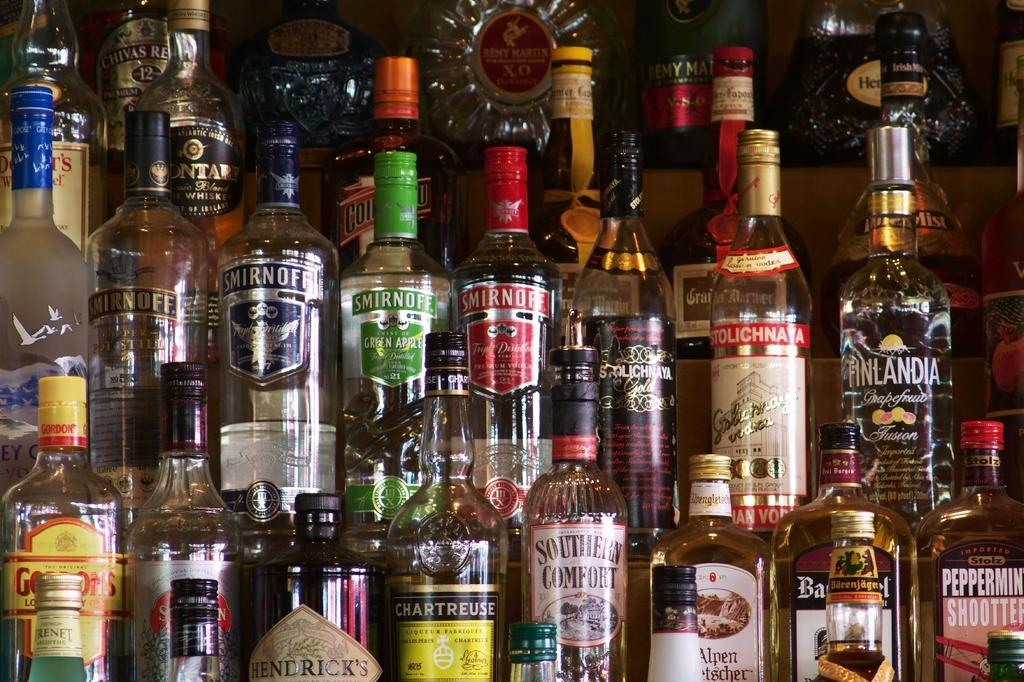<image>
Describe the image concisely. Multiple liquor bottles displayed, including a bottle of Southern Comfort and Finlandia. 